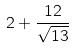<formula> <loc_0><loc_0><loc_500><loc_500>2 + \frac { 1 2 } { \sqrt { 1 3 } }</formula> 